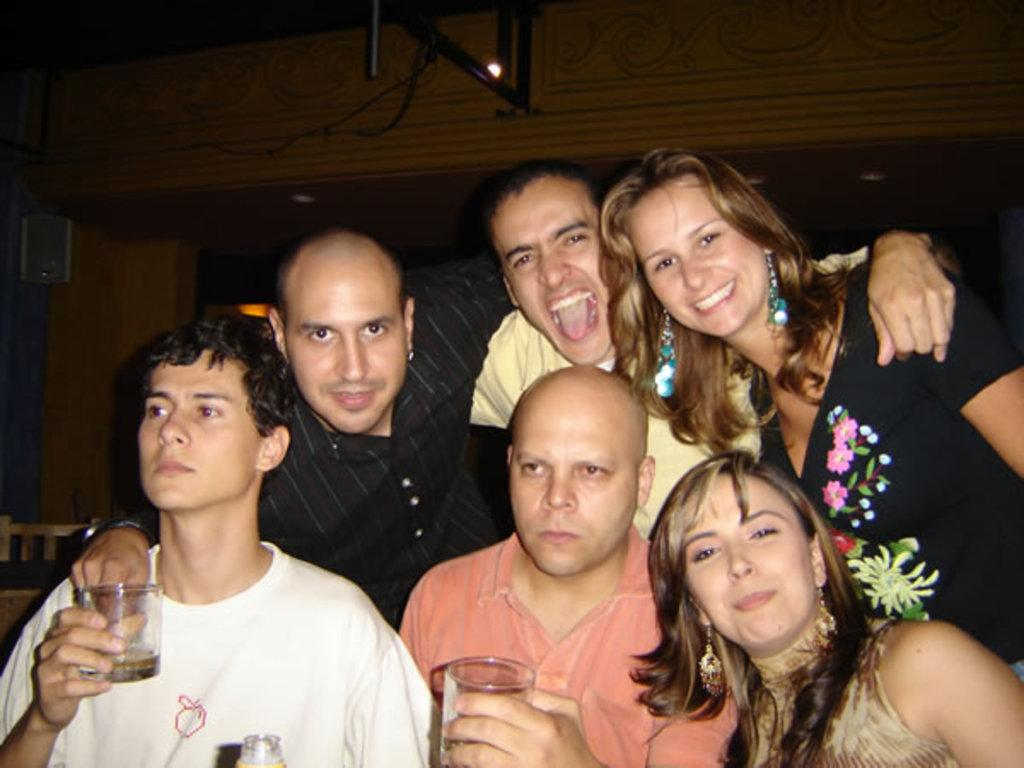How many people are present in the image? There are many people in the image. Where was the image taken? The image was taken in a room. What are the two men in the front of the image doing? The two men in the front of the image are holding glasses. What can be seen in the background of the image? There is a wall and a stand in the background of the image. What type of sack can be seen on the stand in the background of the image? There is no sack present on the stand in the background of the image. What order are the people in the image following? The image does not depict any specific order or sequence of actions. 